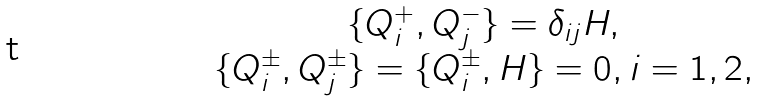<formula> <loc_0><loc_0><loc_500><loc_500>\begin{array} { c } \{ Q _ { i } ^ { + } , Q _ { j } ^ { - } \} = \delta _ { i j } H , \\ \{ Q _ { i } ^ { \pm } , Q _ { j } ^ { \pm } \} = \{ Q _ { i } ^ { \pm } , H \} = 0 , i = 1 , 2 , \end{array}</formula> 